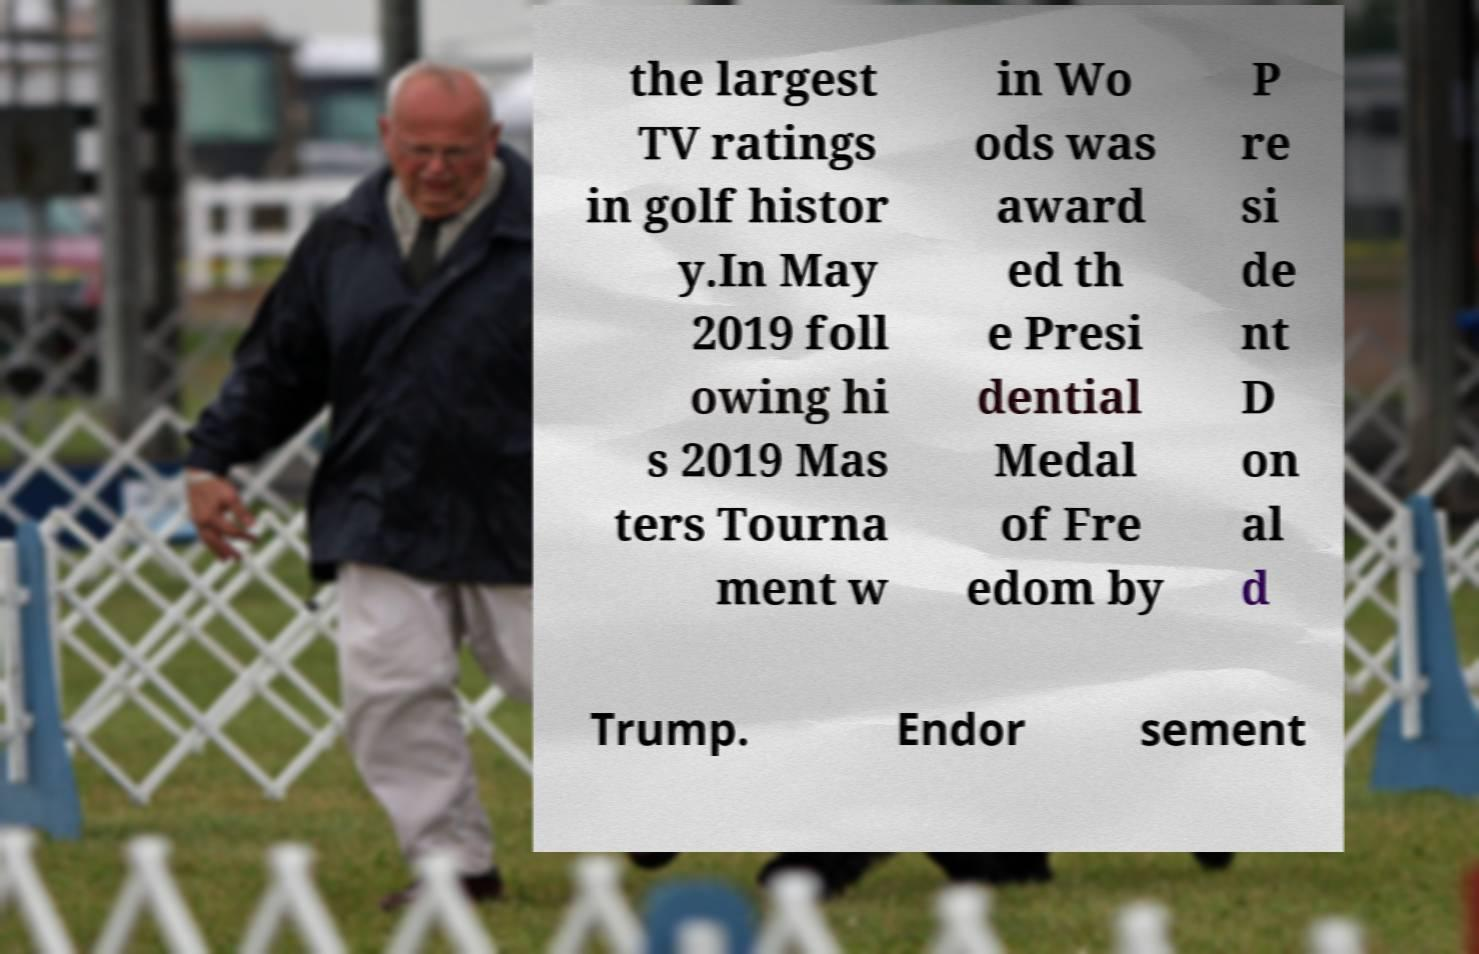Could you extract and type out the text from this image? the largest TV ratings in golf histor y.In May 2019 foll owing hi s 2019 Mas ters Tourna ment w in Wo ods was award ed th e Presi dential Medal of Fre edom by P re si de nt D on al d Trump. Endor sement 